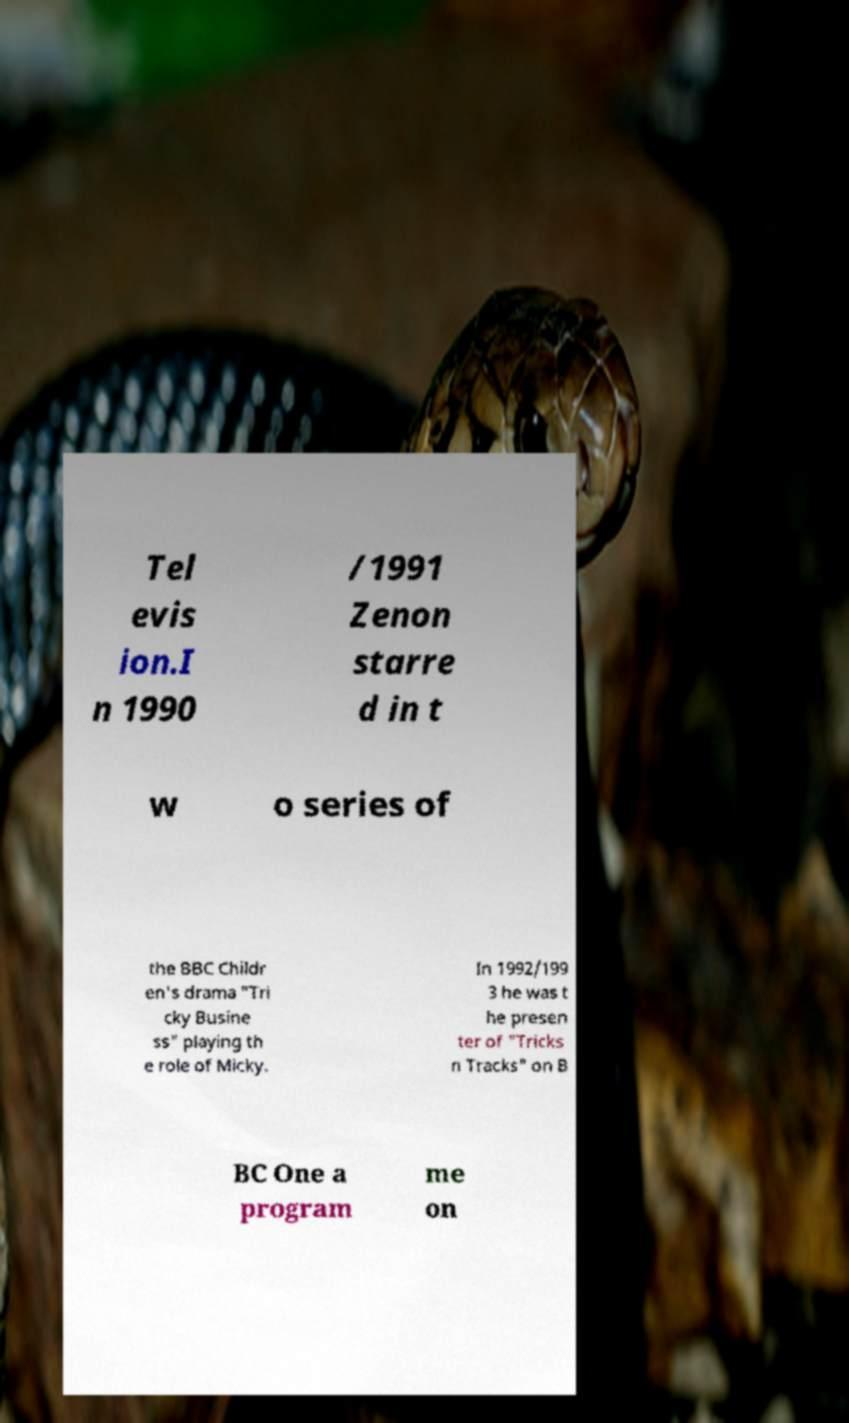I need the written content from this picture converted into text. Can you do that? Tel evis ion.I n 1990 /1991 Zenon starre d in t w o series of the BBC Childr en's drama "Tri cky Busine ss" playing th e role of Micky. In 1992/199 3 he was t he presen ter of "Tricks n Tracks" on B BC One a program me on 